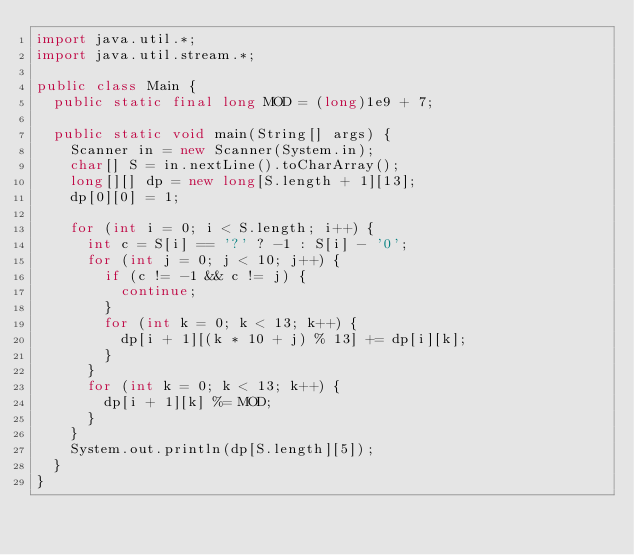<code> <loc_0><loc_0><loc_500><loc_500><_Java_>import java.util.*;
import java.util.stream.*;

public class Main {
  public static final long MOD = (long)1e9 + 7;

  public static void main(String[] args) {
    Scanner in = new Scanner(System.in);
    char[] S = in.nextLine().toCharArray();
    long[][] dp = new long[S.length + 1][13];
    dp[0][0] = 1;

    for (int i = 0; i < S.length; i++) {
      int c = S[i] == '?' ? -1 : S[i] - '0';
      for (int j = 0; j < 10; j++) {
        if (c != -1 && c != j) {
          continue;
        }
        for (int k = 0; k < 13; k++) {
          dp[i + 1][(k * 10 + j) % 13] += dp[i][k];
        }
      }
      for (int k = 0; k < 13; k++) {
        dp[i + 1][k] %= MOD;
      }
    }
    System.out.println(dp[S.length][5]);
  }
}</code> 